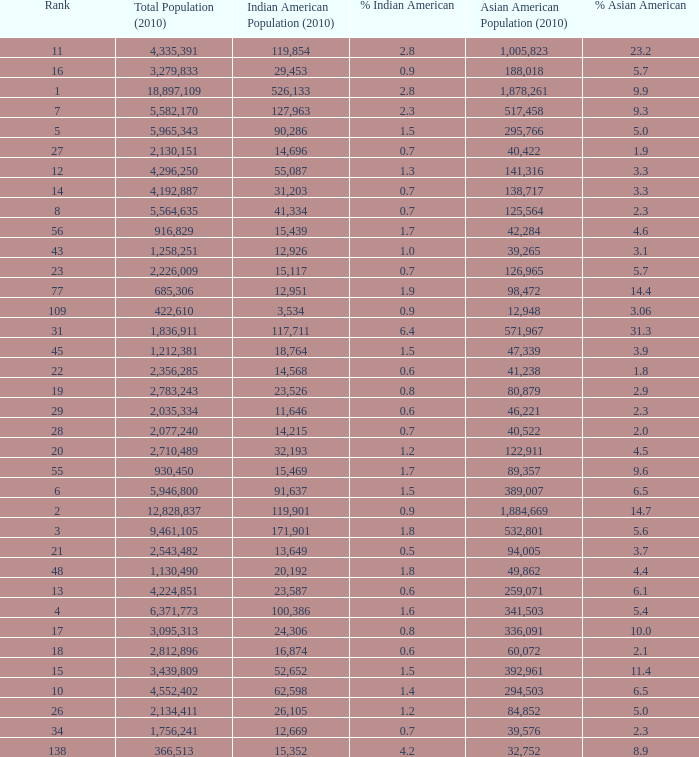What's the total population when the Asian American population is less than 60,072, the Indian American population is more than 14,696 and is 4.2% Indian American? 366513.0. 